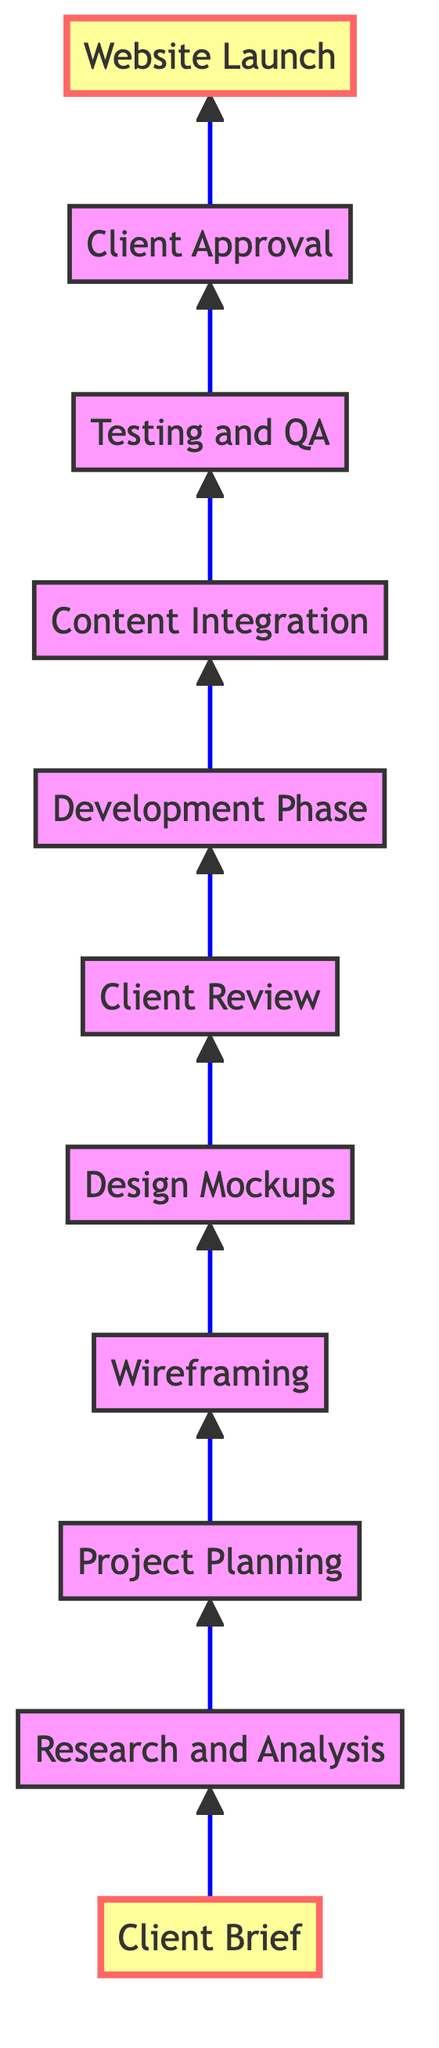What is the first step in the website redesign workflow? The diagram shows that the first step is "Client Brief," which is the starting point where initial discussions with the client take place.
Answer: Client Brief How many steps are there in total from client brief to website launch? By counting the nodes in the diagram, there are a total of eleven steps, starting with "Client Brief" and ending with "Website Launch."
Answer: Eleven What phase comes immediately after "Design Mockups"? The diagram indicates that "Client Review" follows directly after "Design Mockups," where the mockups are presented to the client for feedback.
Answer: Client Review What is the last step before launching the website? According to the flowchart, the step right before "Website Launch" is "Client Approval," which is crucial for final confirmation before going live.
Answer: Client Approval Which step involves developing high-fidelity mockups? From the diagram, "Design Mockups" specifically refers to the phase where high-fidelity mockups are created to visualize the final design of the website.
Answer: Design Mockups How does the "Testing and QA" phase relate to "Development Phase"? The diagram shows that "Testing and QA" comes after "Development Phase," indicating that testing occurs to ensure the website functions correctly after coding.
Answer: Later Which two nodes are marked as important in the diagram? The diagram highlights "Client Brief" at the bottom and "Website Launch" at the top as important nodes, emphasizing their significance in the process flow.
Answer: Client Brief, Website Launch What is the second step in the redesign process? The second step listed in the diagram, following "Client Brief," is "Research and Analysis," which involves gathering insights about the market and competitors.
Answer: Research and Analysis How do "Wireframing" and "Content Integration" connect in the workflow? The diagram shows that "Wireframing" comes before "Content Integration," indicating that wireframes need to be finalized before integrating content into the site.
Answer: Sequentially connected 